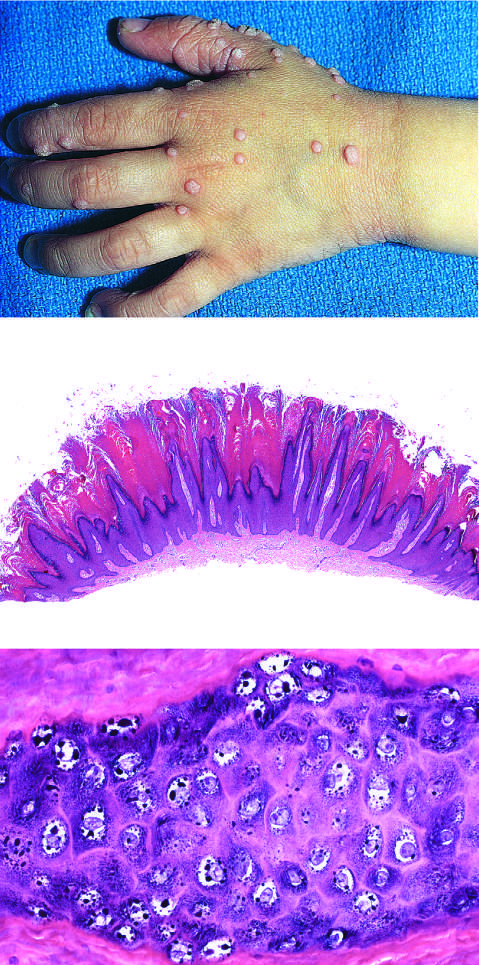what maginification are pallor or halos around nuclei, prominent keratohyalin granules, and related cytopathic changes seen at?
Answer the question using a single word or phrase. Higher magnification 